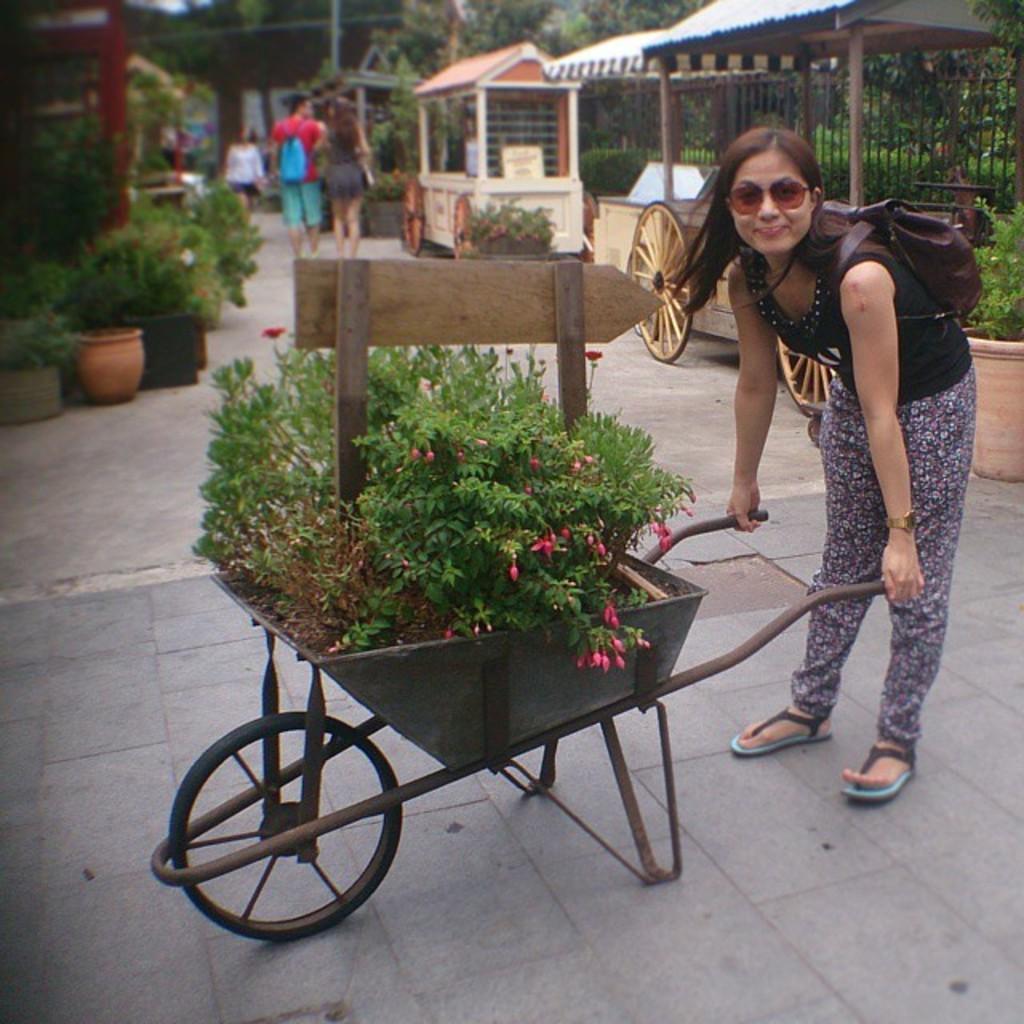Please provide a concise description of this image. In this picture there is a lady on the right side of the image, by holding a trolley of plants in her hands and there are other people, plants, and a net boundary in the background area of the image. 